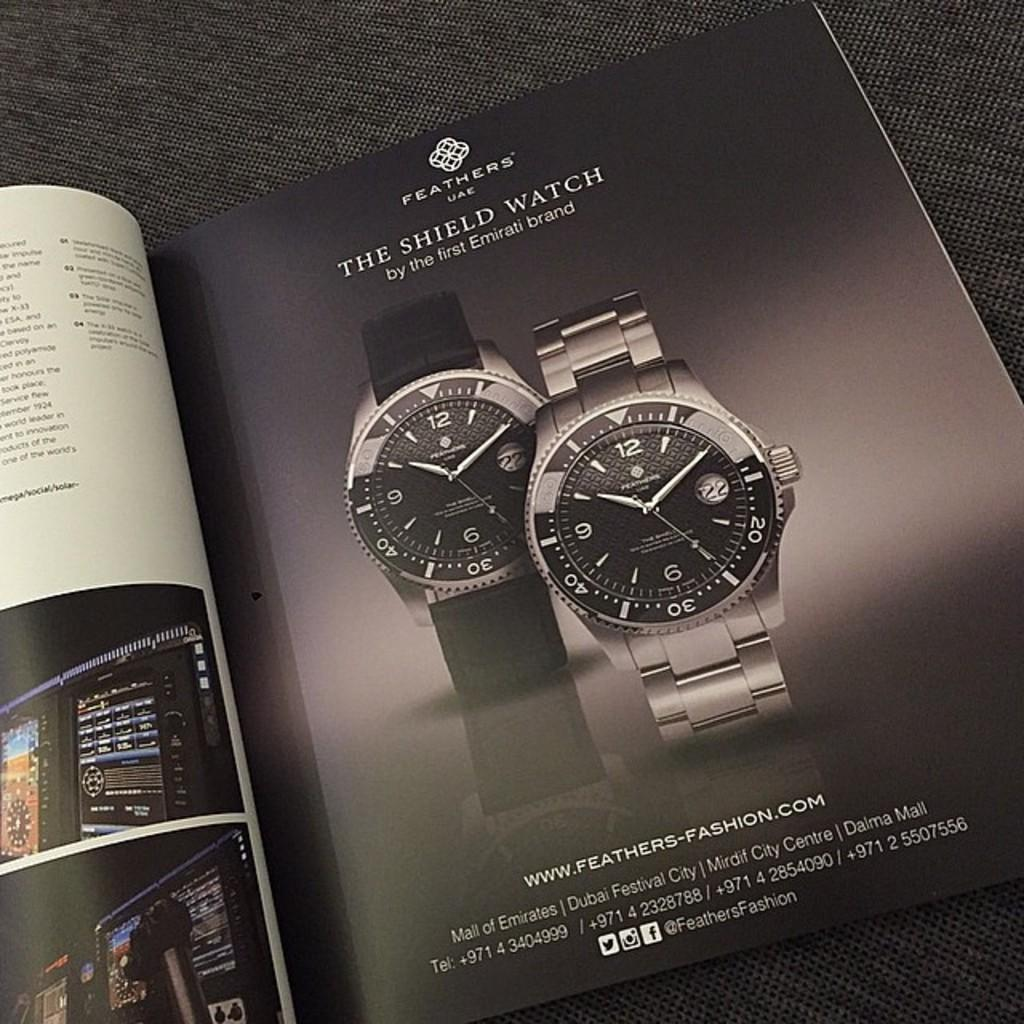What is the main object in the image? There is a book in the image. Where is the book located? The book is on a platform. What type of content does the book contain? The book contains images of watches and text. How many dogs are featured in the book's images? There are no dogs featured in the book's images, as the book contains images of watches. What type of arch can be seen in the image? There is no arch present in the image; it features a book on a platform. 